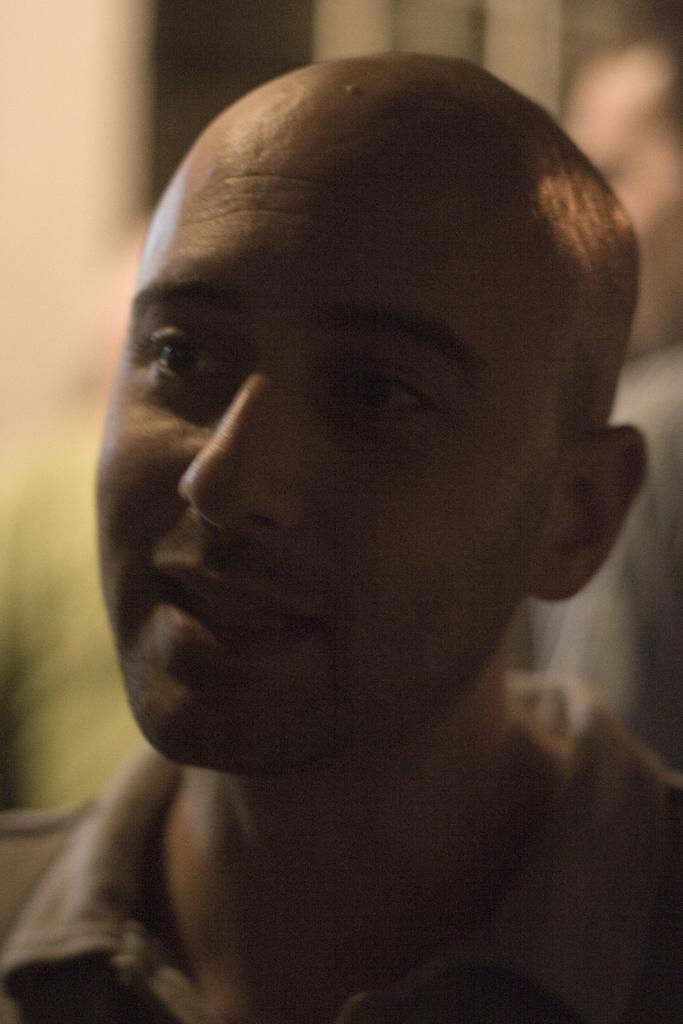In one or two sentences, can you explain what this image depicts? In this image we can see a group of people standing. 